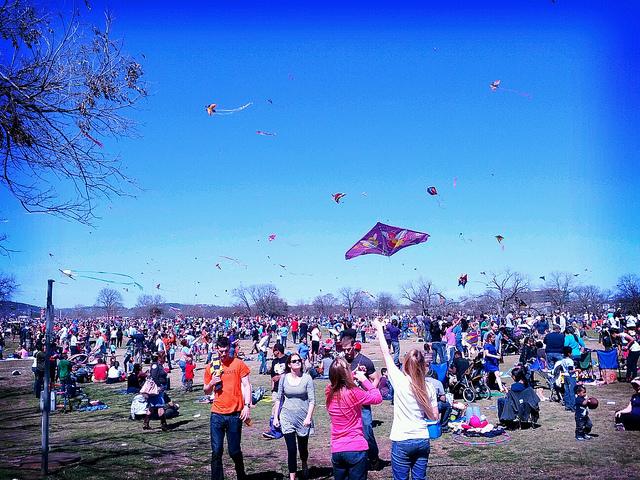Are there many people in the photo?
Quick response, please. Yes. Is the closet kite that is seen flying higher than the other kites?
Short answer required. No. What gender is the person holding the kite?
Write a very short answer. Female. What are the objects in the air?
Answer briefly. Kites. 